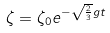Convert formula to latex. <formula><loc_0><loc_0><loc_500><loc_500>\zeta = \zeta _ { 0 } e ^ { - \sqrt { \frac { 2 } { 3 } } g t }</formula> 